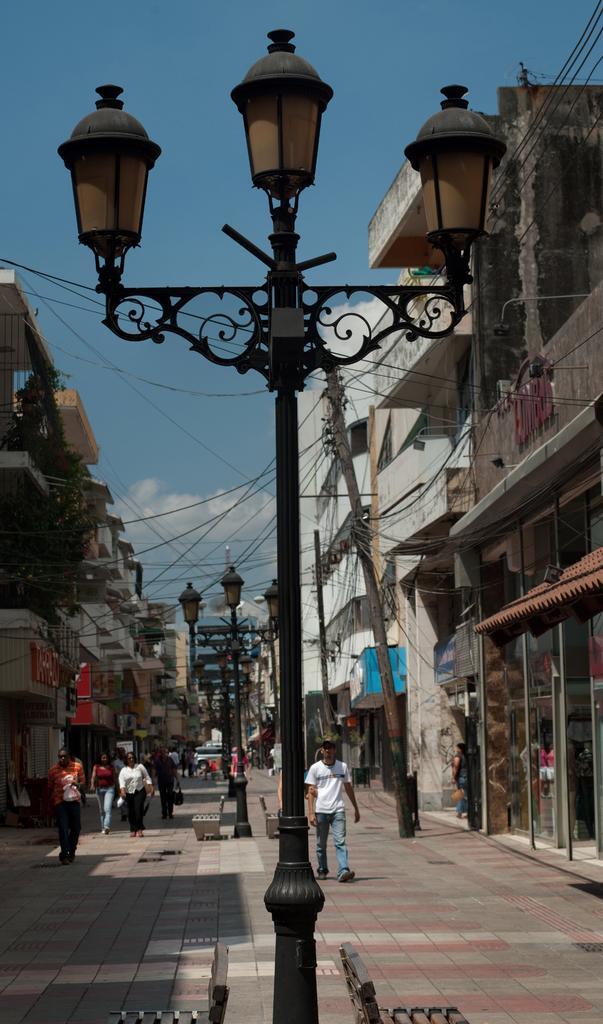Can you describe this image briefly? In this image I can see in the middle there is a pole with lights. At the back side few people are walking, there are buildings on either side. At the top it is the sky. 